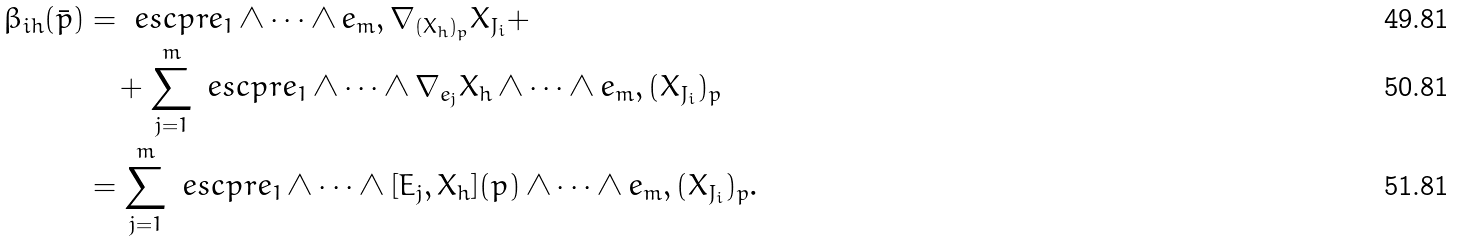Convert formula to latex. <formula><loc_0><loc_0><loc_500><loc_500>\beta _ { i h } ( \bar { p } ) & = \ e s c p r { e _ { 1 } \wedge \dots \wedge e _ { m } , \nabla _ { ( X _ { h } ) _ { p } } X _ { J _ { i } } } + \\ & \quad + \sum _ { j = 1 } ^ { m } \ e s c p r { e _ { 1 } \wedge \dots \wedge \nabla _ { e _ { j } } X _ { h } \wedge \dots \wedge e _ { m } , ( X _ { J _ { i } } ) _ { p } } \\ & = \sum _ { j = 1 } ^ { m } \ e s c p r { e _ { 1 } \wedge \dots \wedge [ E _ { j } , X _ { h } ] ( p ) \wedge \dots \wedge e _ { m } , ( X _ { J _ { i } } ) _ { p } } .</formula> 